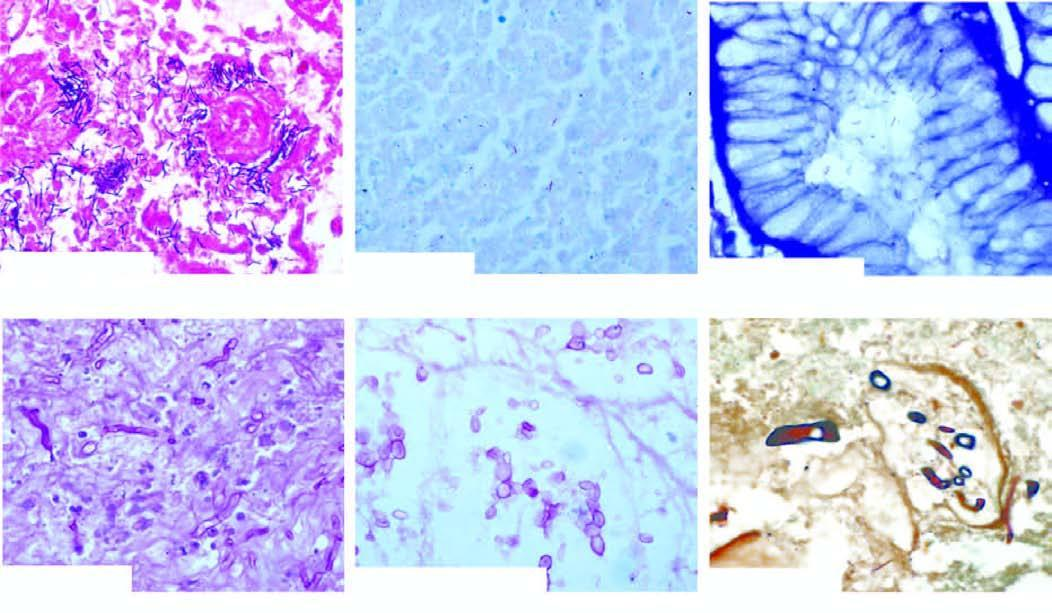what is used for demonstration of microbes?
Answer the question using a single word or phrase. Common stains 